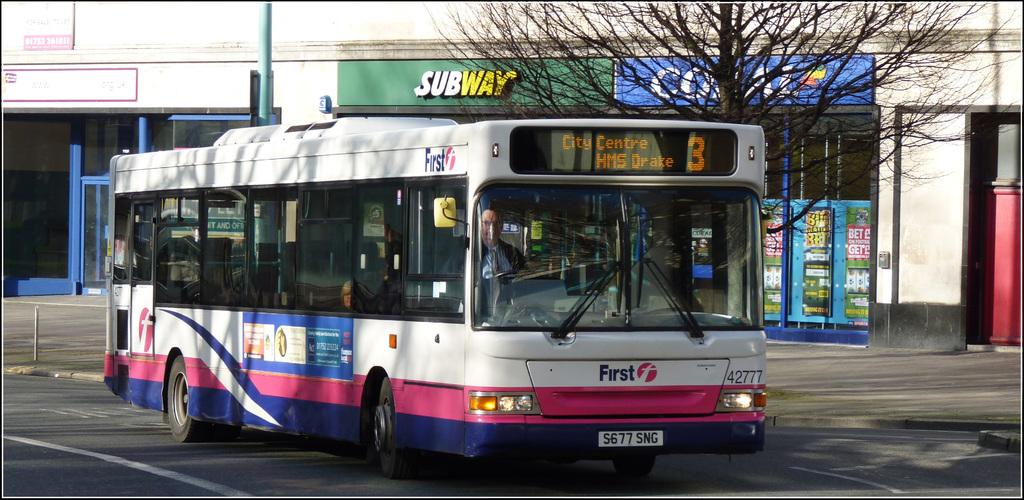<image>
Summarize the visual content of the image. A bus in the street is numbered three and is going to the City Centre. 